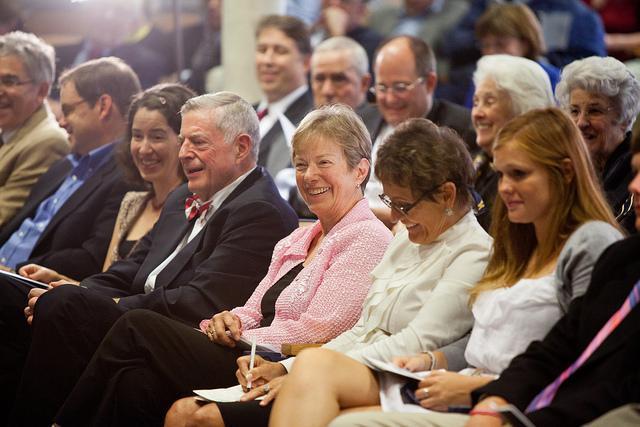How many people are there?
Give a very brief answer. 14. 